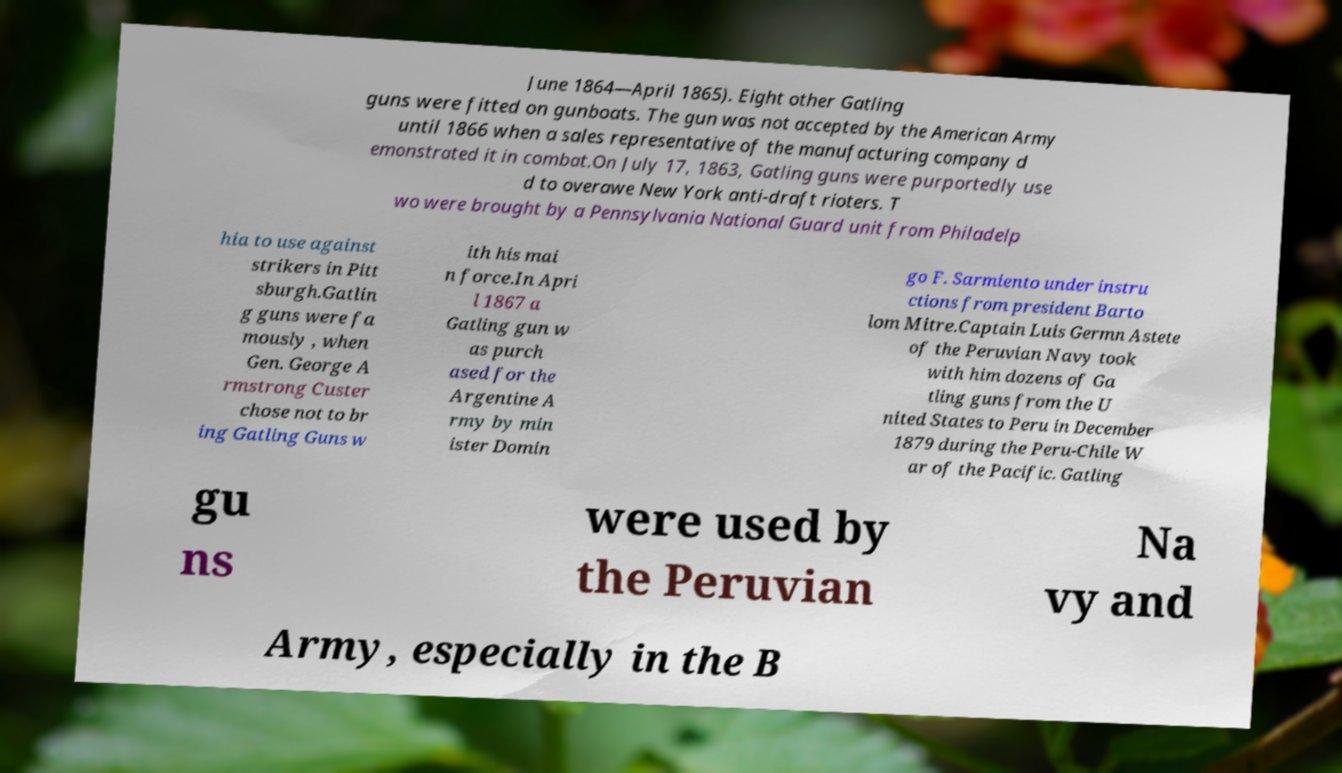What messages or text are displayed in this image? I need them in a readable, typed format. June 1864—April 1865). Eight other Gatling guns were fitted on gunboats. The gun was not accepted by the American Army until 1866 when a sales representative of the manufacturing company d emonstrated it in combat.On July 17, 1863, Gatling guns were purportedly use d to overawe New York anti-draft rioters. T wo were brought by a Pennsylvania National Guard unit from Philadelp hia to use against strikers in Pitt sburgh.Gatlin g guns were fa mously , when Gen. George A rmstrong Custer chose not to br ing Gatling Guns w ith his mai n force.In Apri l 1867 a Gatling gun w as purch ased for the Argentine A rmy by min ister Domin go F. Sarmiento under instru ctions from president Barto lom Mitre.Captain Luis Germn Astete of the Peruvian Navy took with him dozens of Ga tling guns from the U nited States to Peru in December 1879 during the Peru-Chile W ar of the Pacific. Gatling gu ns were used by the Peruvian Na vy and Army, especially in the B 